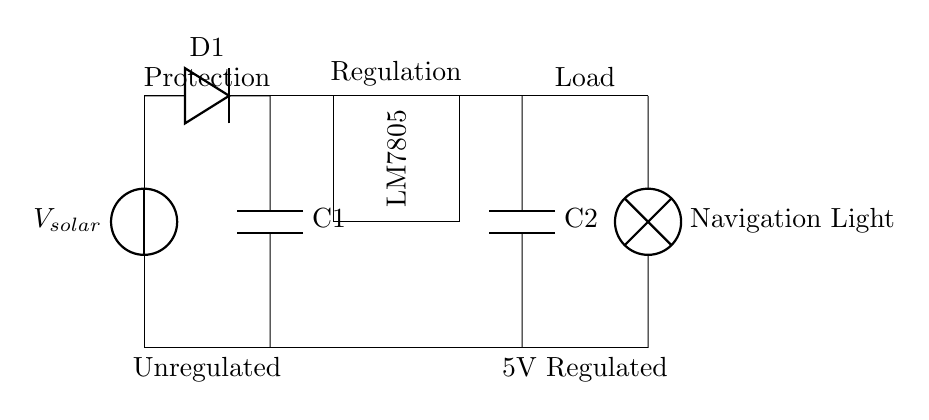What are the main components in this circuit? The circuit has a solar panel, a diode, a voltage regulator (LM7805), capacitors, and a navigation light. Each of these components plays a specific role in converting solar energy to a usable voltage for the light.
Answer: solar panel, diode, voltage regulator, capacitors, navigation light What is the purpose of the diode in the circuit? The diode prevents backflow of current, ensuring that electricity flows only in one direction from the solar panel towards the voltage regulator. This protection is vital to prevent damage to the components.
Answer: prevent backflow What is the output voltage regulated by the LM7805? The LM7805 voltage regulator provides a consistent output of 5 volts, which is necessary to power the navigation lights effectively.
Answer: 5 volts What is the function of the capacitor labeled C1? C1 smooths out fluctuations in the input voltage from the solar panel to the voltage regulator, ensuring a stable current supply. This is essential for maintaining the reliability of the navigation lights.
Answer: smoothing input voltage How does the configuration of this circuit provide protection? The configuration includes a diode to prevent reverse current, a voltage regulator to maintain a steady output voltage, and capacitors to filter noise, collectively protecting the navigation lights from damage due to unstable power.
Answer: diode, voltage regulator, capacitors What does the label "Unregulated" indicate in the circuit? The label "Unregulated" shows that the voltage from the solar panel is variable and not consistent, meaning it can fluctuate based on sunlight availability. It indicates the section before the voltage regulator.
Answer: variable voltage What would happen if the voltage regulator were removed from this circuit? If the voltage regulator were removed, the navigation light would be exposed to the unregulated and fluctuating voltage from the solar panel, which could lead to damage from over-voltage or insufficient power supply.
Answer: potential damage 